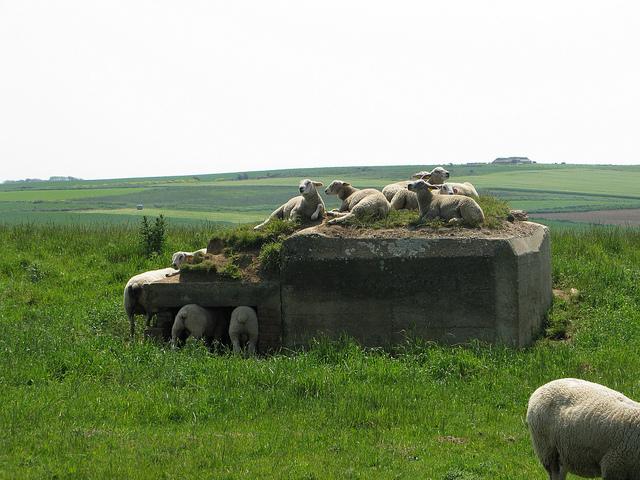What are the sheep laying down on?
Short answer required. Concrete. What color is the grass?
Give a very brief answer. Green. What animals are in the field?
Be succinct. Sheep. 